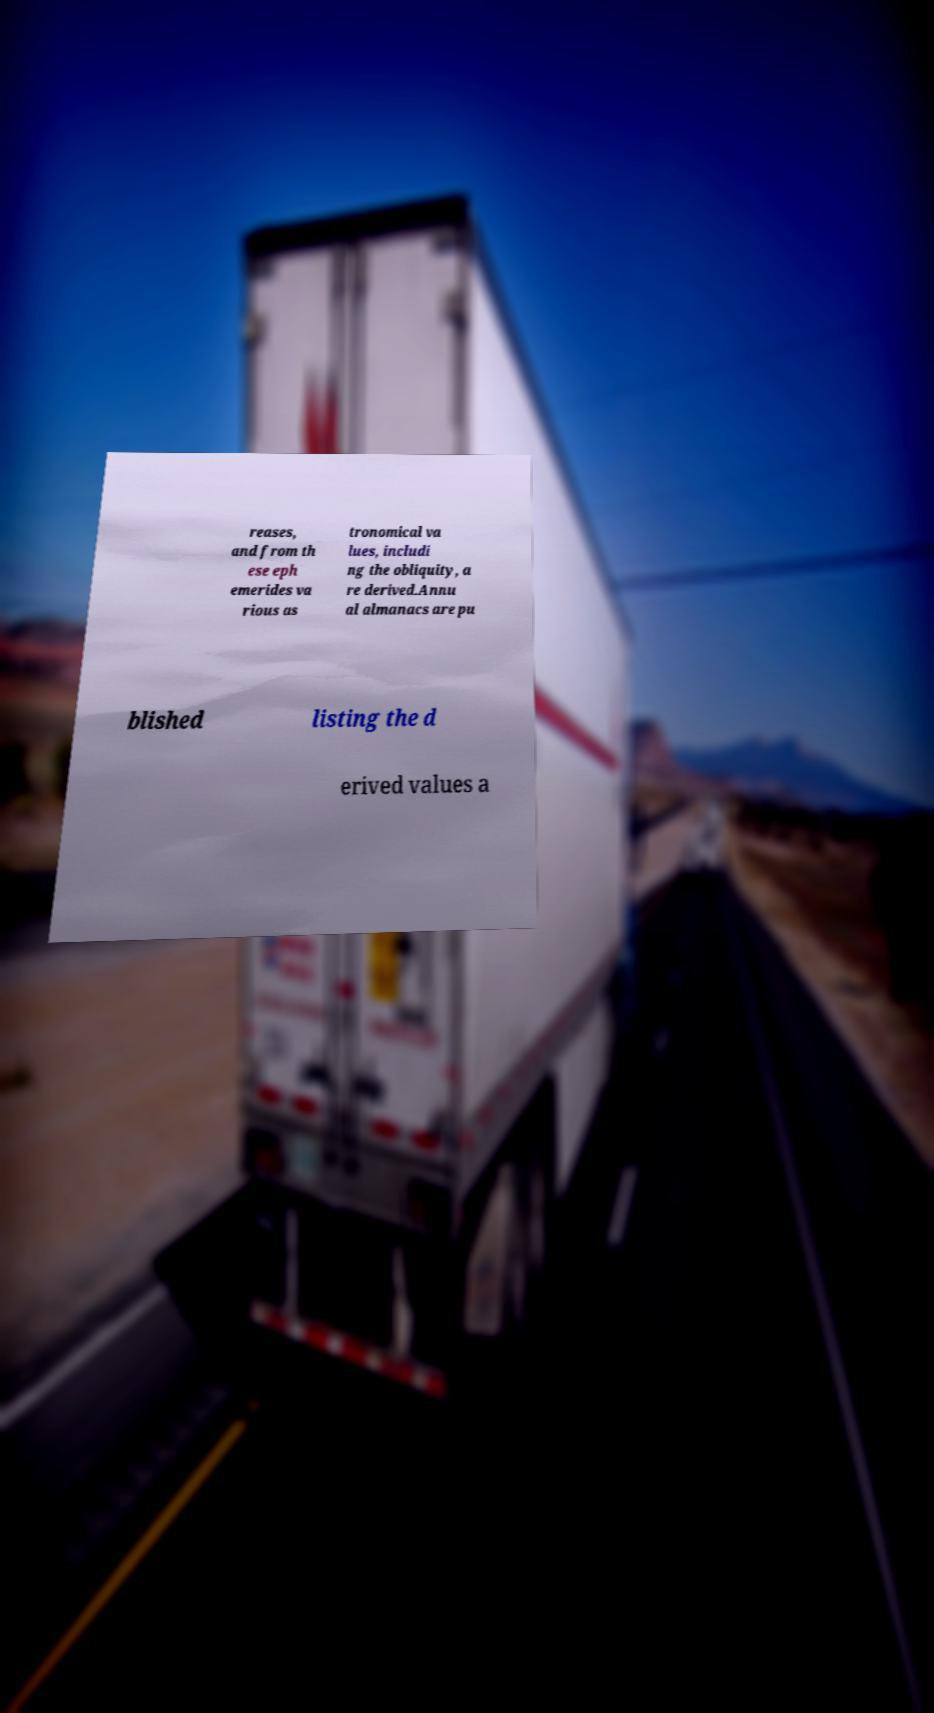Please identify and transcribe the text found in this image. reases, and from th ese eph emerides va rious as tronomical va lues, includi ng the obliquity, a re derived.Annu al almanacs are pu blished listing the d erived values a 